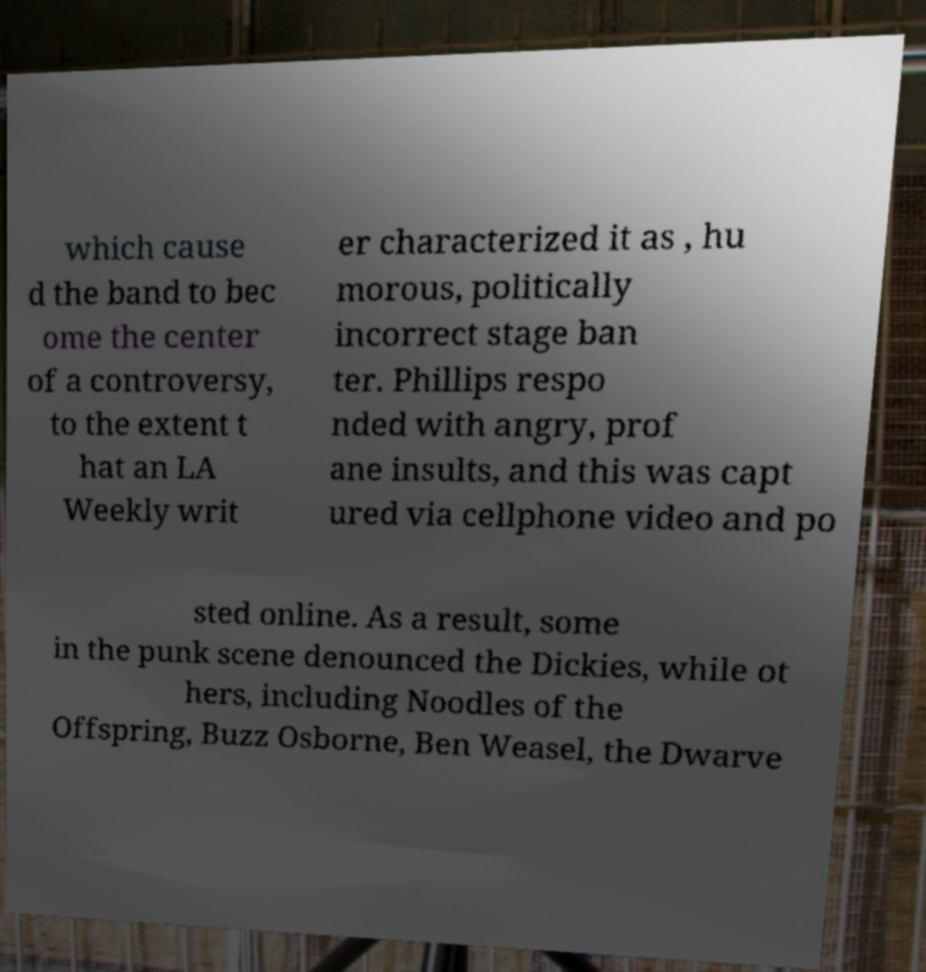I need the written content from this picture converted into text. Can you do that? which cause d the band to bec ome the center of a controversy, to the extent t hat an LA Weekly writ er characterized it as , hu morous, politically incorrect stage ban ter. Phillips respo nded with angry, prof ane insults, and this was capt ured via cellphone video and po sted online. As a result, some in the punk scene denounced the Dickies, while ot hers, including Noodles of the Offspring, Buzz Osborne, Ben Weasel, the Dwarve 